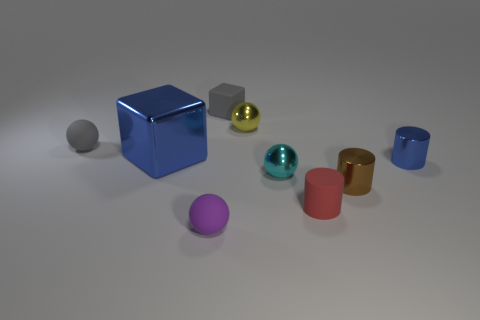Subtract all small red cylinders. How many cylinders are left? 2 Subtract 2 cylinders. How many cylinders are left? 1 Subtract all spheres. How many objects are left? 5 Subtract all cyan spheres. How many spheres are left? 3 Subtract all tiny gray rubber balls. Subtract all small objects. How many objects are left? 0 Add 6 tiny red objects. How many tiny red objects are left? 7 Add 3 cyan balls. How many cyan balls exist? 4 Subtract 1 gray spheres. How many objects are left? 8 Subtract all gray cubes. Subtract all gray spheres. How many cubes are left? 1 